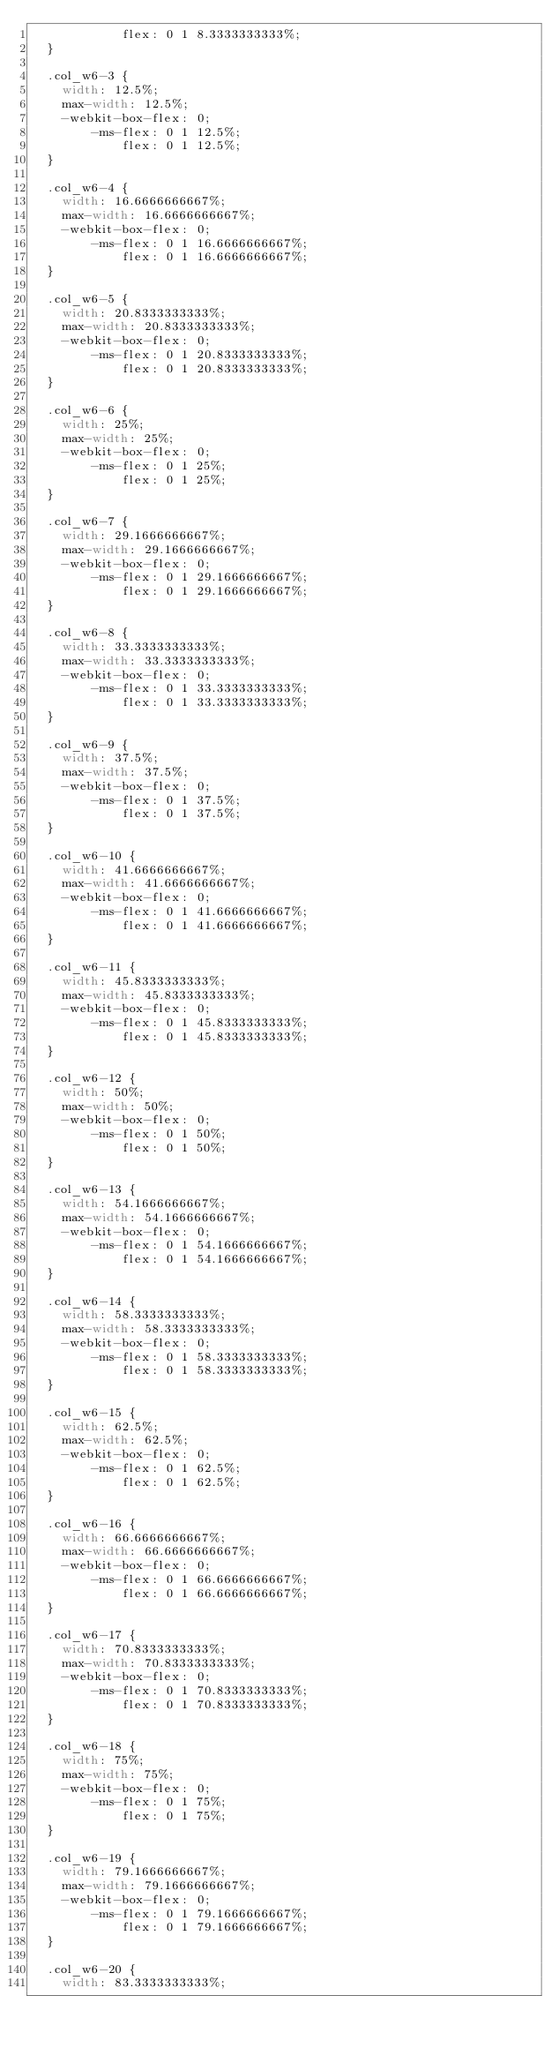Convert code to text. <code><loc_0><loc_0><loc_500><loc_500><_CSS_>            flex: 0 1 8.3333333333%;
  }

  .col_w6-3 {
    width: 12.5%;
    max-width: 12.5%;
    -webkit-box-flex: 0;
        -ms-flex: 0 1 12.5%;
            flex: 0 1 12.5%;
  }

  .col_w6-4 {
    width: 16.6666666667%;
    max-width: 16.6666666667%;
    -webkit-box-flex: 0;
        -ms-flex: 0 1 16.6666666667%;
            flex: 0 1 16.6666666667%;
  }

  .col_w6-5 {
    width: 20.8333333333%;
    max-width: 20.8333333333%;
    -webkit-box-flex: 0;
        -ms-flex: 0 1 20.8333333333%;
            flex: 0 1 20.8333333333%;
  }

  .col_w6-6 {
    width: 25%;
    max-width: 25%;
    -webkit-box-flex: 0;
        -ms-flex: 0 1 25%;
            flex: 0 1 25%;
  }

  .col_w6-7 {
    width: 29.1666666667%;
    max-width: 29.1666666667%;
    -webkit-box-flex: 0;
        -ms-flex: 0 1 29.1666666667%;
            flex: 0 1 29.1666666667%;
  }

  .col_w6-8 {
    width: 33.3333333333%;
    max-width: 33.3333333333%;
    -webkit-box-flex: 0;
        -ms-flex: 0 1 33.3333333333%;
            flex: 0 1 33.3333333333%;
  }

  .col_w6-9 {
    width: 37.5%;
    max-width: 37.5%;
    -webkit-box-flex: 0;
        -ms-flex: 0 1 37.5%;
            flex: 0 1 37.5%;
  }

  .col_w6-10 {
    width: 41.6666666667%;
    max-width: 41.6666666667%;
    -webkit-box-flex: 0;
        -ms-flex: 0 1 41.6666666667%;
            flex: 0 1 41.6666666667%;
  }

  .col_w6-11 {
    width: 45.8333333333%;
    max-width: 45.8333333333%;
    -webkit-box-flex: 0;
        -ms-flex: 0 1 45.8333333333%;
            flex: 0 1 45.8333333333%;
  }

  .col_w6-12 {
    width: 50%;
    max-width: 50%;
    -webkit-box-flex: 0;
        -ms-flex: 0 1 50%;
            flex: 0 1 50%;
  }

  .col_w6-13 {
    width: 54.1666666667%;
    max-width: 54.1666666667%;
    -webkit-box-flex: 0;
        -ms-flex: 0 1 54.1666666667%;
            flex: 0 1 54.1666666667%;
  }

  .col_w6-14 {
    width: 58.3333333333%;
    max-width: 58.3333333333%;
    -webkit-box-flex: 0;
        -ms-flex: 0 1 58.3333333333%;
            flex: 0 1 58.3333333333%;
  }

  .col_w6-15 {
    width: 62.5%;
    max-width: 62.5%;
    -webkit-box-flex: 0;
        -ms-flex: 0 1 62.5%;
            flex: 0 1 62.5%;
  }

  .col_w6-16 {
    width: 66.6666666667%;
    max-width: 66.6666666667%;
    -webkit-box-flex: 0;
        -ms-flex: 0 1 66.6666666667%;
            flex: 0 1 66.6666666667%;
  }

  .col_w6-17 {
    width: 70.8333333333%;
    max-width: 70.8333333333%;
    -webkit-box-flex: 0;
        -ms-flex: 0 1 70.8333333333%;
            flex: 0 1 70.8333333333%;
  }

  .col_w6-18 {
    width: 75%;
    max-width: 75%;
    -webkit-box-flex: 0;
        -ms-flex: 0 1 75%;
            flex: 0 1 75%;
  }

  .col_w6-19 {
    width: 79.1666666667%;
    max-width: 79.1666666667%;
    -webkit-box-flex: 0;
        -ms-flex: 0 1 79.1666666667%;
            flex: 0 1 79.1666666667%;
  }

  .col_w6-20 {
    width: 83.3333333333%;</code> 